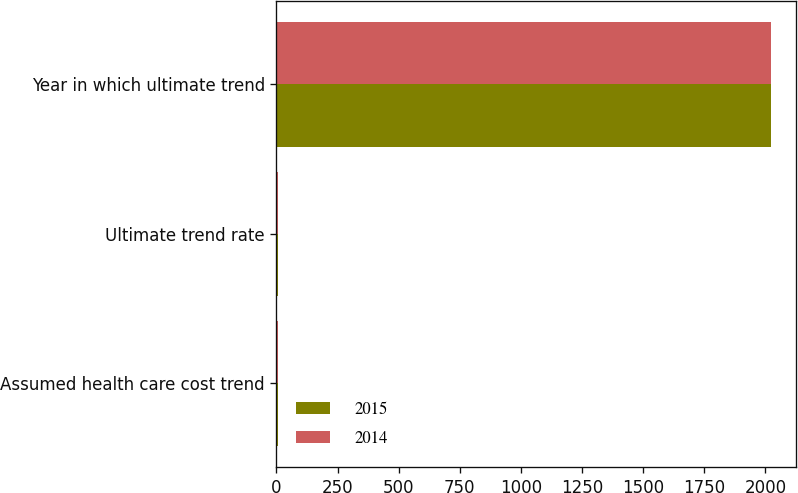<chart> <loc_0><loc_0><loc_500><loc_500><stacked_bar_chart><ecel><fcel>Assumed health care cost trend<fcel>Ultimate trend rate<fcel>Year in which ultimate trend<nl><fcel>2015<fcel>7<fcel>5<fcel>2024<nl><fcel>2014<fcel>7<fcel>5<fcel>2023<nl></chart> 